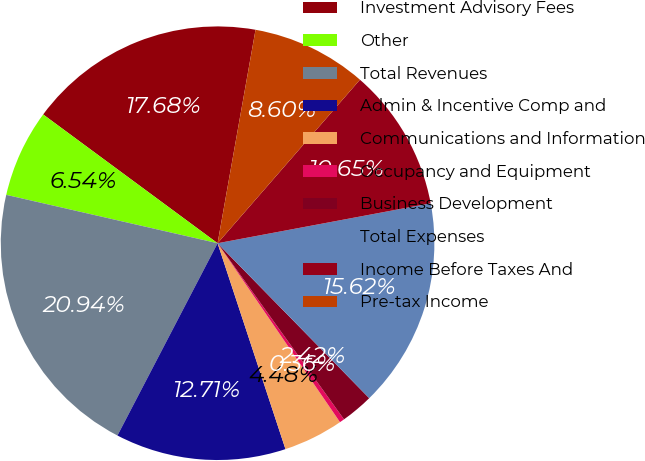Convert chart. <chart><loc_0><loc_0><loc_500><loc_500><pie_chart><fcel>Investment Advisory Fees<fcel>Other<fcel>Total Revenues<fcel>Admin & Incentive Comp and<fcel>Communications and Information<fcel>Occupancy and Equipment<fcel>Business Development<fcel>Total Expenses<fcel>Income Before Taxes And<fcel>Pre-tax Income<nl><fcel>17.68%<fcel>6.54%<fcel>20.94%<fcel>12.71%<fcel>4.48%<fcel>0.36%<fcel>2.42%<fcel>15.62%<fcel>10.65%<fcel>8.6%<nl></chart> 